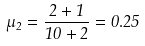Convert formula to latex. <formula><loc_0><loc_0><loc_500><loc_500>\mu _ { 2 } = \frac { 2 + 1 } { 1 0 + 2 } = 0 . 2 5</formula> 